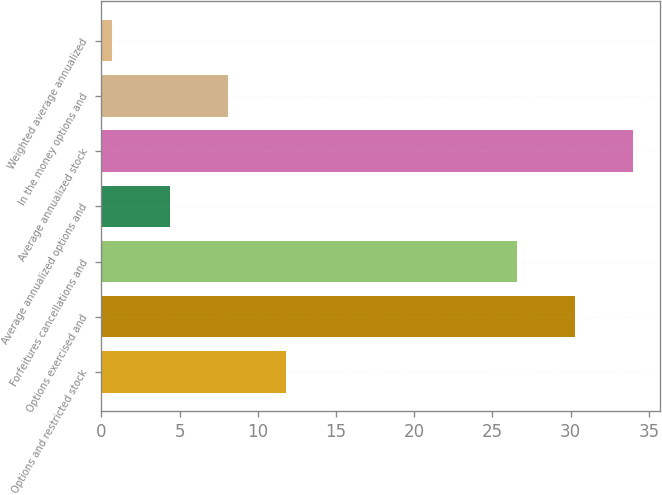Convert chart. <chart><loc_0><loc_0><loc_500><loc_500><bar_chart><fcel>Options and restricted stock<fcel>Options exercised and<fcel>Forfeitures cancellations and<fcel>Average annualized options and<fcel>Average annualized stock<fcel>In the money options and<fcel>Weighted average annualized<nl><fcel>11.8<fcel>30.3<fcel>26.6<fcel>4.4<fcel>34<fcel>8.1<fcel>0.7<nl></chart> 